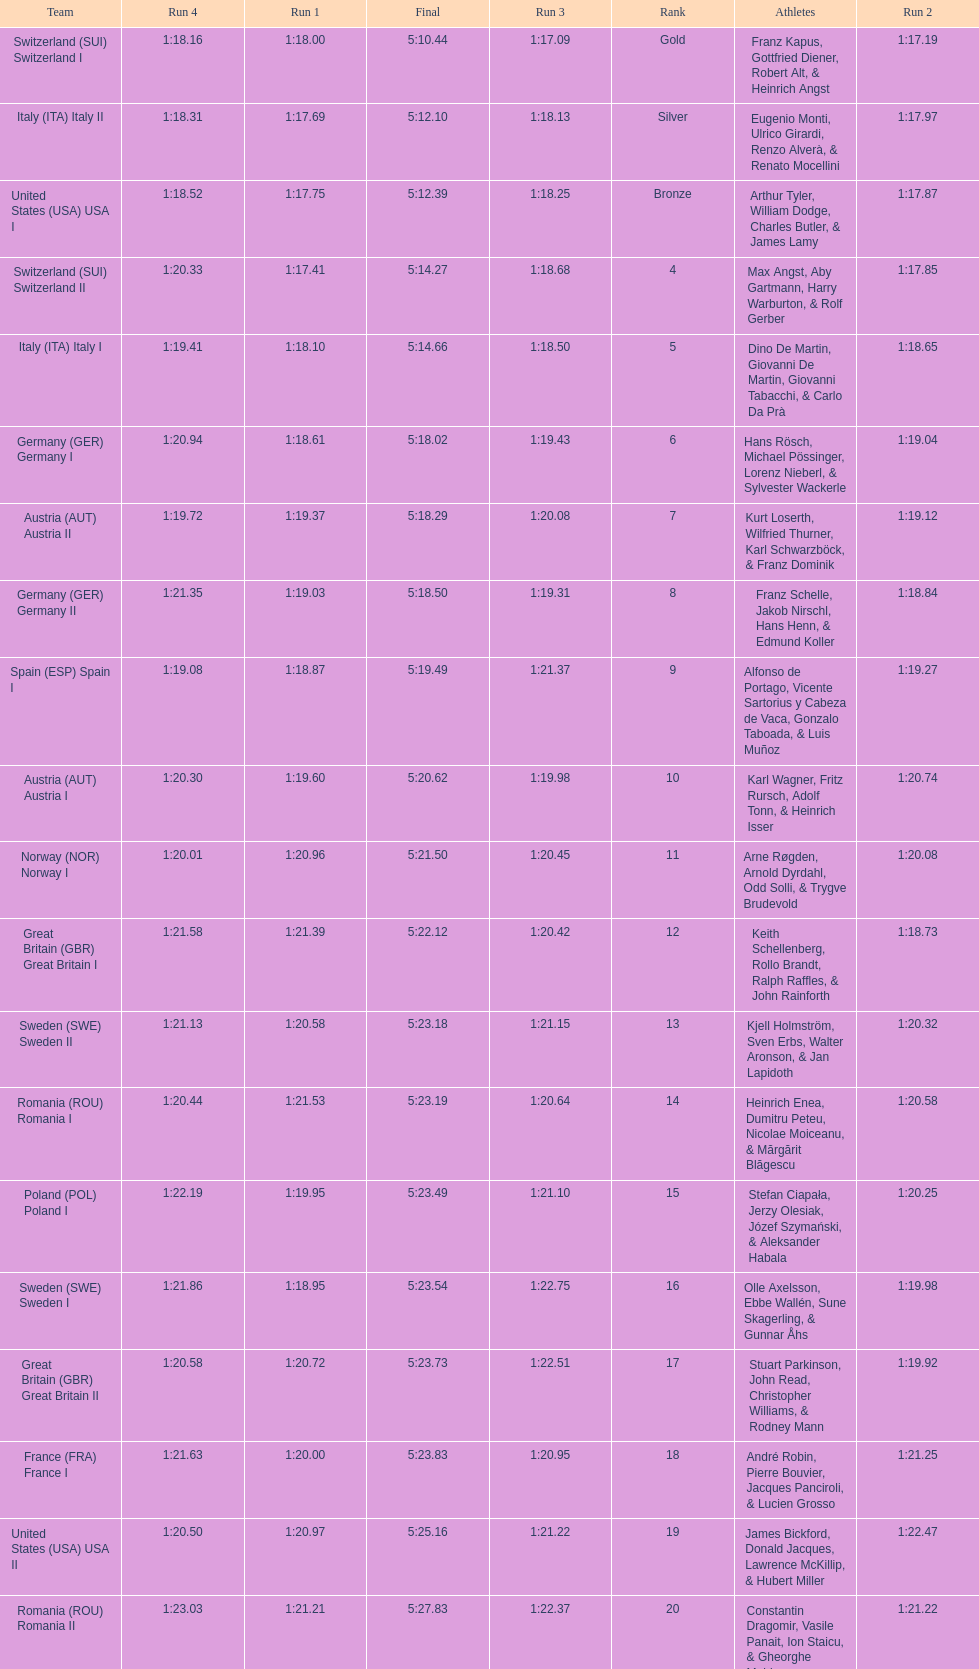What is the total amount of runs? 4. 